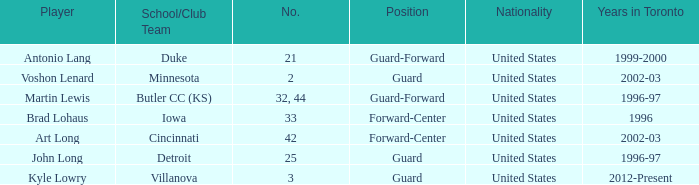How many schools did player number 3 play at? 1.0. 